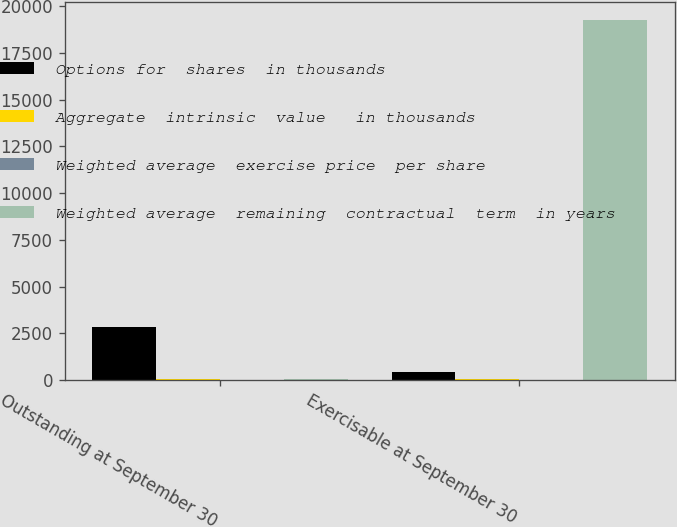Convert chart. <chart><loc_0><loc_0><loc_500><loc_500><stacked_bar_chart><ecel><fcel>Outstanding at September 30<fcel>Exercisable at September 30<nl><fcel>Options for  shares  in thousands<fcel>2836<fcel>451<nl><fcel>Aggregate  intrinsic  value   in thousands<fcel>51.63<fcel>41.62<nl><fcel>Weighted average  exercise price  per share<fcel>3.58<fcel>2.37<nl><fcel>Weighted average  remaining  contractual  term  in years<fcel>51.63<fcel>19246<nl></chart> 